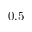<formula> <loc_0><loc_0><loc_500><loc_500>0 . 5</formula> 